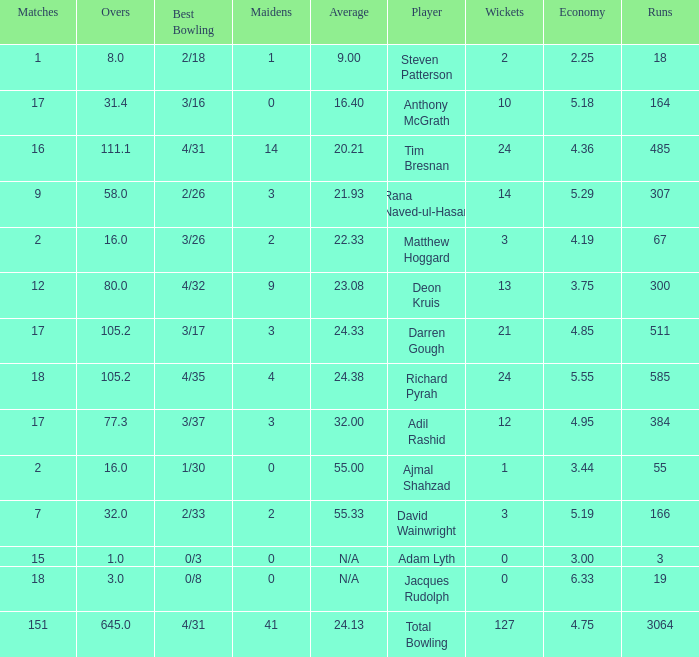What is the lowest Overs with a Run that is 18? 8.0. Can you give me this table as a dict? {'header': ['Matches', 'Overs', 'Best Bowling', 'Maidens', 'Average', 'Player', 'Wickets', 'Economy', 'Runs'], 'rows': [['1', '8.0', '2/18', '1', '9.00', 'Steven Patterson', '2', '2.25', '18'], ['17', '31.4', '3/16', '0', '16.40', 'Anthony McGrath', '10', '5.18', '164'], ['16', '111.1', '4/31', '14', '20.21', 'Tim Bresnan', '24', '4.36', '485'], ['9', '58.0', '2/26', '3', '21.93', 'Rana Naved-ul-Hasan', '14', '5.29', '307'], ['2', '16.0', '3/26', '2', '22.33', 'Matthew Hoggard', '3', '4.19', '67'], ['12', '80.0', '4/32', '9', '23.08', 'Deon Kruis', '13', '3.75', '300'], ['17', '105.2', '3/17', '3', '24.33', 'Darren Gough', '21', '4.85', '511'], ['18', '105.2', '4/35', '4', '24.38', 'Richard Pyrah', '24', '5.55', '585'], ['17', '77.3', '3/37', '3', '32.00', 'Adil Rashid', '12', '4.95', '384'], ['2', '16.0', '1/30', '0', '55.00', 'Ajmal Shahzad', '1', '3.44', '55'], ['7', '32.0', '2/33', '2', '55.33', 'David Wainwright', '3', '5.19', '166'], ['15', '1.0', '0/3', '0', 'N/A', 'Adam Lyth', '0', '3.00', '3'], ['18', '3.0', '0/8', '0', 'N/A', 'Jacques Rudolph', '0', '6.33', '19'], ['151', '645.0', '4/31', '41', '24.13', 'Total Bowling', '127', '4.75', '3064']]} 